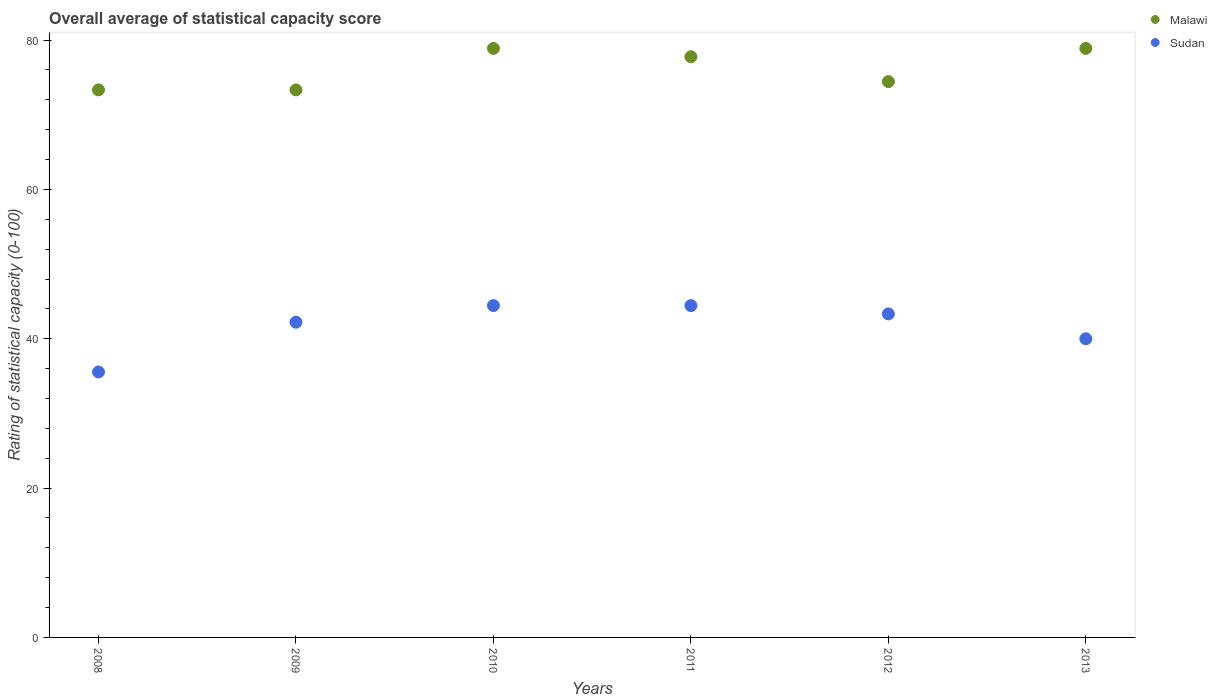How many different coloured dotlines are there?
Provide a succinct answer. 2. What is the rating of statistical capacity in Sudan in 2013?
Offer a very short reply. 40. Across all years, what is the maximum rating of statistical capacity in Sudan?
Your answer should be compact. 44.44. Across all years, what is the minimum rating of statistical capacity in Sudan?
Keep it short and to the point. 35.56. What is the total rating of statistical capacity in Sudan in the graph?
Your answer should be compact. 250. What is the difference between the rating of statistical capacity in Sudan in 2010 and that in 2013?
Offer a terse response. 4.44. What is the difference between the rating of statistical capacity in Sudan in 2008 and the rating of statistical capacity in Malawi in 2009?
Your answer should be very brief. -37.78. What is the average rating of statistical capacity in Malawi per year?
Offer a terse response. 76.11. In the year 2008, what is the difference between the rating of statistical capacity in Malawi and rating of statistical capacity in Sudan?
Offer a very short reply. 37.78. What is the ratio of the rating of statistical capacity in Sudan in 2009 to that in 2010?
Make the answer very short. 0.95. What is the difference between the highest and the lowest rating of statistical capacity in Malawi?
Keep it short and to the point. 5.56. In how many years, is the rating of statistical capacity in Malawi greater than the average rating of statistical capacity in Malawi taken over all years?
Your answer should be very brief. 3. Does the rating of statistical capacity in Malawi monotonically increase over the years?
Keep it short and to the point. No. Is the rating of statistical capacity in Malawi strictly greater than the rating of statistical capacity in Sudan over the years?
Ensure brevity in your answer.  Yes. Is the rating of statistical capacity in Sudan strictly less than the rating of statistical capacity in Malawi over the years?
Ensure brevity in your answer.  Yes. How many years are there in the graph?
Offer a very short reply. 6. What is the difference between two consecutive major ticks on the Y-axis?
Give a very brief answer. 20. Does the graph contain grids?
Your response must be concise. No. Where does the legend appear in the graph?
Keep it short and to the point. Top right. How are the legend labels stacked?
Make the answer very short. Vertical. What is the title of the graph?
Make the answer very short. Overall average of statistical capacity score. Does "Palau" appear as one of the legend labels in the graph?
Make the answer very short. No. What is the label or title of the Y-axis?
Make the answer very short. Rating of statistical capacity (0-100). What is the Rating of statistical capacity (0-100) in Malawi in 2008?
Your answer should be compact. 73.33. What is the Rating of statistical capacity (0-100) of Sudan in 2008?
Your answer should be very brief. 35.56. What is the Rating of statistical capacity (0-100) of Malawi in 2009?
Ensure brevity in your answer.  73.33. What is the Rating of statistical capacity (0-100) of Sudan in 2009?
Offer a terse response. 42.22. What is the Rating of statistical capacity (0-100) in Malawi in 2010?
Make the answer very short. 78.89. What is the Rating of statistical capacity (0-100) of Sudan in 2010?
Keep it short and to the point. 44.44. What is the Rating of statistical capacity (0-100) in Malawi in 2011?
Keep it short and to the point. 77.78. What is the Rating of statistical capacity (0-100) in Sudan in 2011?
Your answer should be very brief. 44.44. What is the Rating of statistical capacity (0-100) of Malawi in 2012?
Offer a terse response. 74.44. What is the Rating of statistical capacity (0-100) in Sudan in 2012?
Ensure brevity in your answer.  43.33. What is the Rating of statistical capacity (0-100) of Malawi in 2013?
Ensure brevity in your answer.  78.89. Across all years, what is the maximum Rating of statistical capacity (0-100) in Malawi?
Keep it short and to the point. 78.89. Across all years, what is the maximum Rating of statistical capacity (0-100) of Sudan?
Give a very brief answer. 44.44. Across all years, what is the minimum Rating of statistical capacity (0-100) of Malawi?
Provide a short and direct response. 73.33. Across all years, what is the minimum Rating of statistical capacity (0-100) of Sudan?
Make the answer very short. 35.56. What is the total Rating of statistical capacity (0-100) in Malawi in the graph?
Keep it short and to the point. 456.67. What is the total Rating of statistical capacity (0-100) in Sudan in the graph?
Your response must be concise. 250. What is the difference between the Rating of statistical capacity (0-100) in Sudan in 2008 and that in 2009?
Make the answer very short. -6.67. What is the difference between the Rating of statistical capacity (0-100) of Malawi in 2008 and that in 2010?
Your answer should be compact. -5.56. What is the difference between the Rating of statistical capacity (0-100) of Sudan in 2008 and that in 2010?
Make the answer very short. -8.89. What is the difference between the Rating of statistical capacity (0-100) in Malawi in 2008 and that in 2011?
Offer a terse response. -4.44. What is the difference between the Rating of statistical capacity (0-100) of Sudan in 2008 and that in 2011?
Provide a short and direct response. -8.89. What is the difference between the Rating of statistical capacity (0-100) in Malawi in 2008 and that in 2012?
Make the answer very short. -1.11. What is the difference between the Rating of statistical capacity (0-100) of Sudan in 2008 and that in 2012?
Give a very brief answer. -7.78. What is the difference between the Rating of statistical capacity (0-100) in Malawi in 2008 and that in 2013?
Provide a short and direct response. -5.56. What is the difference between the Rating of statistical capacity (0-100) of Sudan in 2008 and that in 2013?
Your response must be concise. -4.44. What is the difference between the Rating of statistical capacity (0-100) of Malawi in 2009 and that in 2010?
Make the answer very short. -5.56. What is the difference between the Rating of statistical capacity (0-100) in Sudan in 2009 and that in 2010?
Offer a terse response. -2.22. What is the difference between the Rating of statistical capacity (0-100) of Malawi in 2009 and that in 2011?
Your response must be concise. -4.44. What is the difference between the Rating of statistical capacity (0-100) of Sudan in 2009 and that in 2011?
Give a very brief answer. -2.22. What is the difference between the Rating of statistical capacity (0-100) of Malawi in 2009 and that in 2012?
Keep it short and to the point. -1.11. What is the difference between the Rating of statistical capacity (0-100) in Sudan in 2009 and that in 2012?
Offer a very short reply. -1.11. What is the difference between the Rating of statistical capacity (0-100) in Malawi in 2009 and that in 2013?
Your answer should be compact. -5.56. What is the difference between the Rating of statistical capacity (0-100) of Sudan in 2009 and that in 2013?
Ensure brevity in your answer.  2.22. What is the difference between the Rating of statistical capacity (0-100) in Sudan in 2010 and that in 2011?
Keep it short and to the point. 0. What is the difference between the Rating of statistical capacity (0-100) in Malawi in 2010 and that in 2012?
Your answer should be compact. 4.44. What is the difference between the Rating of statistical capacity (0-100) in Sudan in 2010 and that in 2012?
Your answer should be compact. 1.11. What is the difference between the Rating of statistical capacity (0-100) of Sudan in 2010 and that in 2013?
Provide a succinct answer. 4.44. What is the difference between the Rating of statistical capacity (0-100) in Sudan in 2011 and that in 2012?
Keep it short and to the point. 1.11. What is the difference between the Rating of statistical capacity (0-100) of Malawi in 2011 and that in 2013?
Your answer should be very brief. -1.11. What is the difference between the Rating of statistical capacity (0-100) in Sudan in 2011 and that in 2013?
Your response must be concise. 4.44. What is the difference between the Rating of statistical capacity (0-100) in Malawi in 2012 and that in 2013?
Give a very brief answer. -4.44. What is the difference between the Rating of statistical capacity (0-100) in Malawi in 2008 and the Rating of statistical capacity (0-100) in Sudan in 2009?
Offer a terse response. 31.11. What is the difference between the Rating of statistical capacity (0-100) in Malawi in 2008 and the Rating of statistical capacity (0-100) in Sudan in 2010?
Your response must be concise. 28.89. What is the difference between the Rating of statistical capacity (0-100) of Malawi in 2008 and the Rating of statistical capacity (0-100) of Sudan in 2011?
Provide a succinct answer. 28.89. What is the difference between the Rating of statistical capacity (0-100) of Malawi in 2008 and the Rating of statistical capacity (0-100) of Sudan in 2012?
Offer a terse response. 30. What is the difference between the Rating of statistical capacity (0-100) in Malawi in 2008 and the Rating of statistical capacity (0-100) in Sudan in 2013?
Provide a short and direct response. 33.33. What is the difference between the Rating of statistical capacity (0-100) of Malawi in 2009 and the Rating of statistical capacity (0-100) of Sudan in 2010?
Provide a succinct answer. 28.89. What is the difference between the Rating of statistical capacity (0-100) in Malawi in 2009 and the Rating of statistical capacity (0-100) in Sudan in 2011?
Provide a succinct answer. 28.89. What is the difference between the Rating of statistical capacity (0-100) of Malawi in 2009 and the Rating of statistical capacity (0-100) of Sudan in 2013?
Provide a short and direct response. 33.33. What is the difference between the Rating of statistical capacity (0-100) of Malawi in 2010 and the Rating of statistical capacity (0-100) of Sudan in 2011?
Your answer should be very brief. 34.44. What is the difference between the Rating of statistical capacity (0-100) in Malawi in 2010 and the Rating of statistical capacity (0-100) in Sudan in 2012?
Give a very brief answer. 35.56. What is the difference between the Rating of statistical capacity (0-100) in Malawi in 2010 and the Rating of statistical capacity (0-100) in Sudan in 2013?
Provide a succinct answer. 38.89. What is the difference between the Rating of statistical capacity (0-100) in Malawi in 2011 and the Rating of statistical capacity (0-100) in Sudan in 2012?
Offer a very short reply. 34.44. What is the difference between the Rating of statistical capacity (0-100) of Malawi in 2011 and the Rating of statistical capacity (0-100) of Sudan in 2013?
Keep it short and to the point. 37.78. What is the difference between the Rating of statistical capacity (0-100) of Malawi in 2012 and the Rating of statistical capacity (0-100) of Sudan in 2013?
Offer a very short reply. 34.44. What is the average Rating of statistical capacity (0-100) in Malawi per year?
Make the answer very short. 76.11. What is the average Rating of statistical capacity (0-100) in Sudan per year?
Give a very brief answer. 41.67. In the year 2008, what is the difference between the Rating of statistical capacity (0-100) of Malawi and Rating of statistical capacity (0-100) of Sudan?
Keep it short and to the point. 37.78. In the year 2009, what is the difference between the Rating of statistical capacity (0-100) of Malawi and Rating of statistical capacity (0-100) of Sudan?
Your response must be concise. 31.11. In the year 2010, what is the difference between the Rating of statistical capacity (0-100) of Malawi and Rating of statistical capacity (0-100) of Sudan?
Your answer should be compact. 34.44. In the year 2011, what is the difference between the Rating of statistical capacity (0-100) in Malawi and Rating of statistical capacity (0-100) in Sudan?
Provide a short and direct response. 33.33. In the year 2012, what is the difference between the Rating of statistical capacity (0-100) in Malawi and Rating of statistical capacity (0-100) in Sudan?
Give a very brief answer. 31.11. In the year 2013, what is the difference between the Rating of statistical capacity (0-100) in Malawi and Rating of statistical capacity (0-100) in Sudan?
Your response must be concise. 38.89. What is the ratio of the Rating of statistical capacity (0-100) in Malawi in 2008 to that in 2009?
Keep it short and to the point. 1. What is the ratio of the Rating of statistical capacity (0-100) of Sudan in 2008 to that in 2009?
Provide a succinct answer. 0.84. What is the ratio of the Rating of statistical capacity (0-100) in Malawi in 2008 to that in 2010?
Offer a very short reply. 0.93. What is the ratio of the Rating of statistical capacity (0-100) in Sudan in 2008 to that in 2010?
Your answer should be compact. 0.8. What is the ratio of the Rating of statistical capacity (0-100) of Malawi in 2008 to that in 2011?
Provide a short and direct response. 0.94. What is the ratio of the Rating of statistical capacity (0-100) in Sudan in 2008 to that in 2011?
Offer a terse response. 0.8. What is the ratio of the Rating of statistical capacity (0-100) of Malawi in 2008 to that in 2012?
Give a very brief answer. 0.99. What is the ratio of the Rating of statistical capacity (0-100) in Sudan in 2008 to that in 2012?
Provide a succinct answer. 0.82. What is the ratio of the Rating of statistical capacity (0-100) in Malawi in 2008 to that in 2013?
Your answer should be compact. 0.93. What is the ratio of the Rating of statistical capacity (0-100) in Malawi in 2009 to that in 2010?
Your answer should be very brief. 0.93. What is the ratio of the Rating of statistical capacity (0-100) of Sudan in 2009 to that in 2010?
Provide a succinct answer. 0.95. What is the ratio of the Rating of statistical capacity (0-100) in Malawi in 2009 to that in 2011?
Your answer should be compact. 0.94. What is the ratio of the Rating of statistical capacity (0-100) in Sudan in 2009 to that in 2011?
Keep it short and to the point. 0.95. What is the ratio of the Rating of statistical capacity (0-100) of Malawi in 2009 to that in 2012?
Keep it short and to the point. 0.99. What is the ratio of the Rating of statistical capacity (0-100) of Sudan in 2009 to that in 2012?
Ensure brevity in your answer.  0.97. What is the ratio of the Rating of statistical capacity (0-100) of Malawi in 2009 to that in 2013?
Ensure brevity in your answer.  0.93. What is the ratio of the Rating of statistical capacity (0-100) of Sudan in 2009 to that in 2013?
Your response must be concise. 1.06. What is the ratio of the Rating of statistical capacity (0-100) of Malawi in 2010 to that in 2011?
Your answer should be compact. 1.01. What is the ratio of the Rating of statistical capacity (0-100) of Sudan in 2010 to that in 2011?
Provide a short and direct response. 1. What is the ratio of the Rating of statistical capacity (0-100) of Malawi in 2010 to that in 2012?
Your answer should be very brief. 1.06. What is the ratio of the Rating of statistical capacity (0-100) in Sudan in 2010 to that in 2012?
Your answer should be very brief. 1.03. What is the ratio of the Rating of statistical capacity (0-100) in Malawi in 2011 to that in 2012?
Ensure brevity in your answer.  1.04. What is the ratio of the Rating of statistical capacity (0-100) of Sudan in 2011 to that in 2012?
Offer a very short reply. 1.03. What is the ratio of the Rating of statistical capacity (0-100) in Malawi in 2011 to that in 2013?
Provide a succinct answer. 0.99. What is the ratio of the Rating of statistical capacity (0-100) in Malawi in 2012 to that in 2013?
Ensure brevity in your answer.  0.94. What is the difference between the highest and the lowest Rating of statistical capacity (0-100) of Malawi?
Your response must be concise. 5.56. What is the difference between the highest and the lowest Rating of statistical capacity (0-100) of Sudan?
Provide a short and direct response. 8.89. 